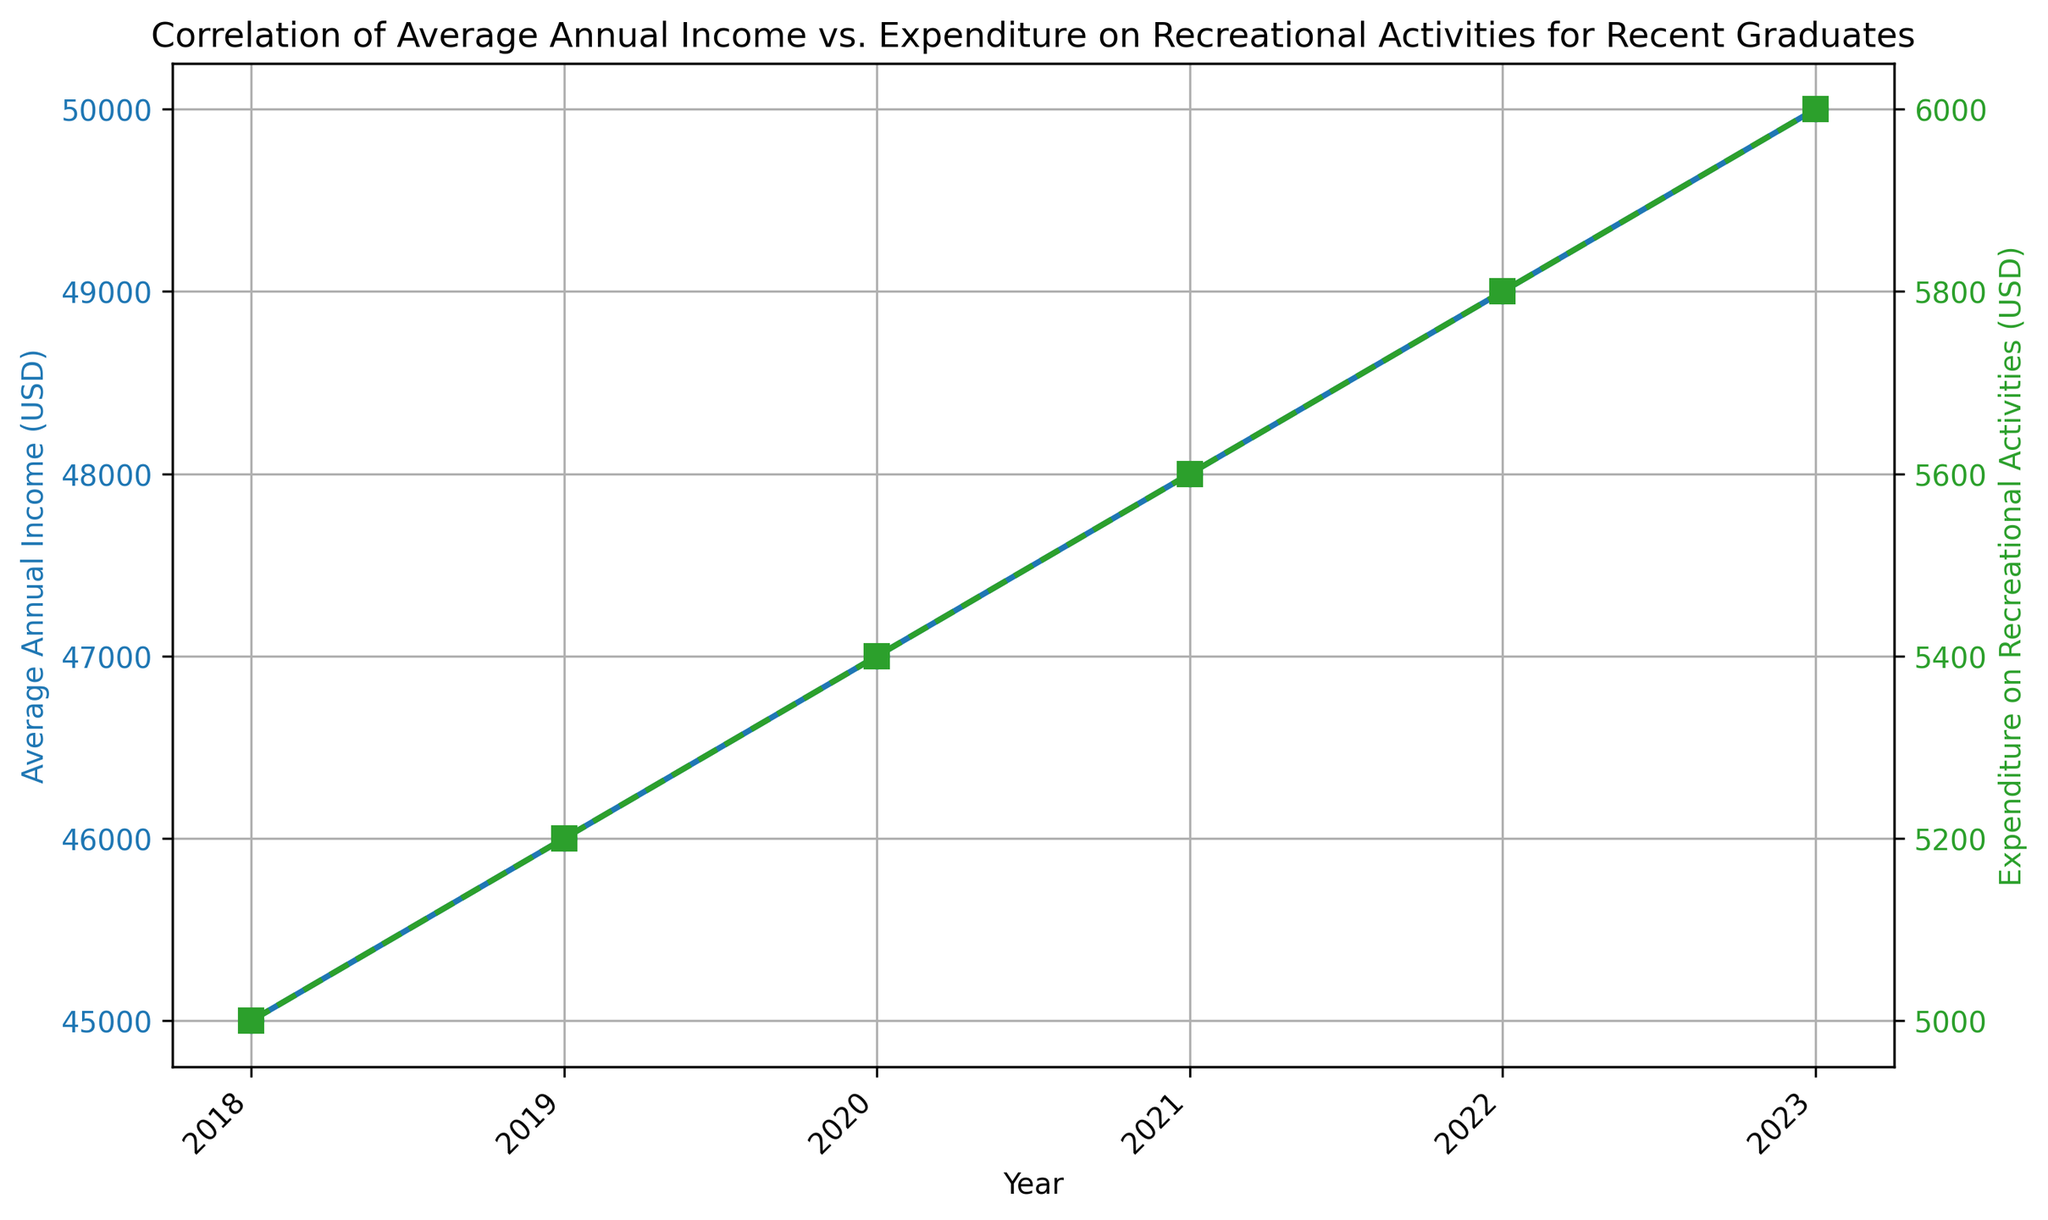What trend can you observe in the average annual income from 2018 to 2023? The average annual income steadily increases each year. Starting from $45,000 in 2018 and reaching $50,000 in 2023. This indicates a consistent year-over-year growth in income for recent graduates.
Answer: Steadily increasing What is the difference between the expenditure on recreational activities in 2023 compared to 2018? To find the difference, subtract the 2018 expenditure from the 2023 expenditure: $6,000 (2023) - $5,000 (2018) = $1,000. This means the expenditure increased by $1,000 over 5 years.
Answer: $1,000 By how much did the average annual income increase every year on average? Calculate the total increase from 2018 ($45,000) to 2023 ($50,000): $50,000 - $45,000 = $5,000. Then divide by the number of years (5): $5,000 / 5 years = $1,000 per year.
Answer: $1,000 per year In which year was the expenditure on recreational activities closest to $5,500? Look at the expenditure values and find the one closest to $5,500. In 2020, the expenditure was $5,400, and in 2021, it was $5,600. The average of these two ($5,400 + $5,600) / 2 = $5,500. Therefore, both these years are equidistant from $5,500.
Answer: 2020 and 2021 How does the growth rate of average annual income compare to the growth rate of expenditure on recreational activities between 2018 and 2023? Calculate the growth rate for both:
Income: (($50,000 - $45,000) / $45,000) * 100 = 11.11%
Expenditure: (($6,000 - $5,000) / $5,000) * 100 = 20%
The expenditure on recreational activities grew at a higher rate than the average annual income.
Answer: Expenditure grew faster What was the average expenditure on recreational activities over the 6 years? Add up all the expenditure values and divide by 6: ($5,000 + $5,200 + $5,400 + $5,600 + $5,800 + $6,000) / 6 = $5,500.
Answer: $5,500 Does the trend in expenditure on recreational activities visually mirror the trend in average annual income? Both trends are represented by steadily increasing lines, with income in blue and expenditure in green, showing a parallel upward movement over the years, suggesting a positive correlation.
Answer: Yes, parallel upward movement In which year did both income and expenditure experience the highest recorded values? By looking at the highest points for both the blue (income) and green (expenditure) lines, the year 2023 shows the highest income ($50,000) and expenditure ($6,000).
Answer: 2023 Are there any years where the increase in expenditure from the previous year was higher than the increase in income? By visually inspecting the slope of the lines between consecutive years:
- From 2018 to 2019: Income increased by $1,000 and expenditure by $200.
- From 2019 to 2020: Income increased by $1,000 and expenditure by $200.
- From 2020 to 2021: Income increased by $1,000 and expenditure by $200.
- From 2021 to 2022: Income increased by $1,000 and expenditure by $200.
- From 2022 to 2023: Income increased by $1,000 and expenditure by $200.
In no year does the increase in expenditure surpass the increase in income.
Answer: No 